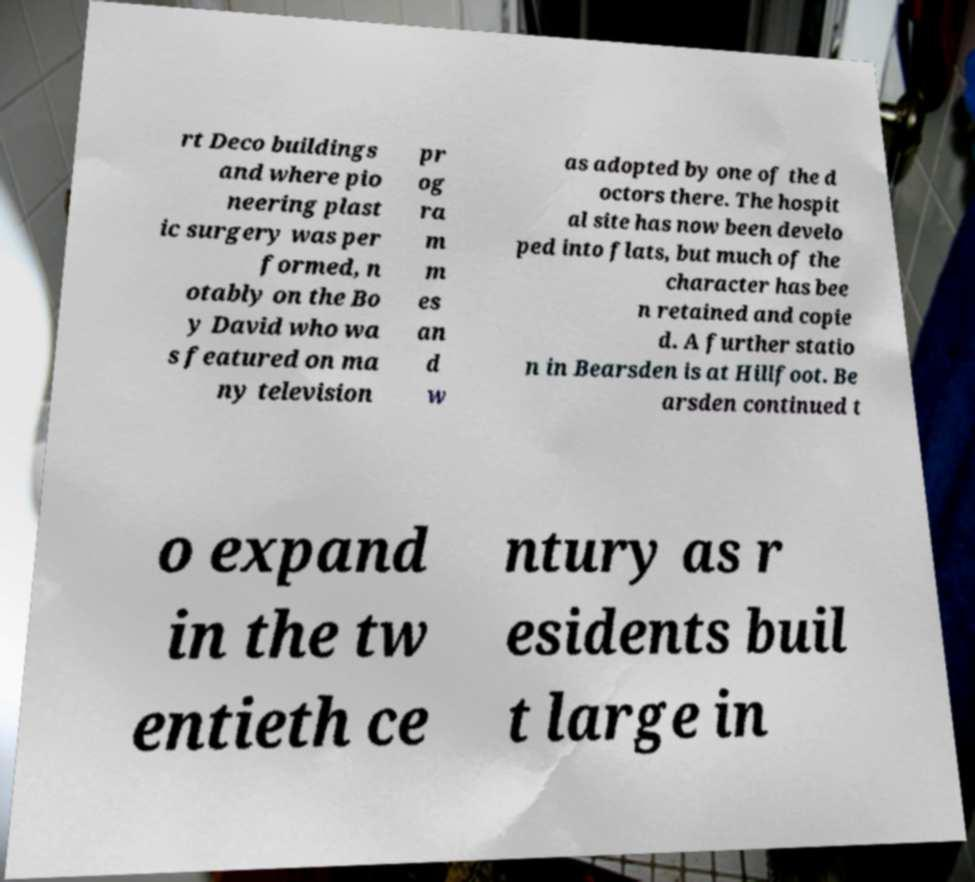I need the written content from this picture converted into text. Can you do that? rt Deco buildings and where pio neering plast ic surgery was per formed, n otably on the Bo y David who wa s featured on ma ny television pr og ra m m es an d w as adopted by one of the d octors there. The hospit al site has now been develo ped into flats, but much of the character has bee n retained and copie d. A further statio n in Bearsden is at Hillfoot. Be arsden continued t o expand in the tw entieth ce ntury as r esidents buil t large in 